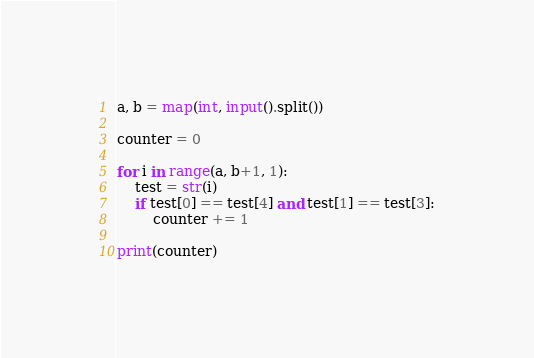Convert code to text. <code><loc_0><loc_0><loc_500><loc_500><_Python_>a, b = map(int, input().split())

counter = 0

for i in range(a, b+1, 1):
    test = str(i)
    if test[0] == test[4] and test[1] == test[3]:
        counter += 1
    
print(counter)</code> 